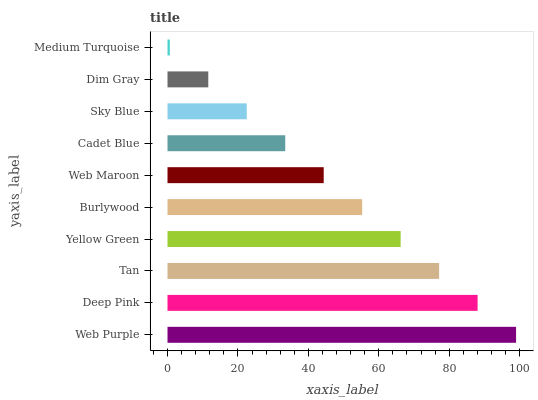Is Medium Turquoise the minimum?
Answer yes or no. Yes. Is Web Purple the maximum?
Answer yes or no. Yes. Is Deep Pink the minimum?
Answer yes or no. No. Is Deep Pink the maximum?
Answer yes or no. No. Is Web Purple greater than Deep Pink?
Answer yes or no. Yes. Is Deep Pink less than Web Purple?
Answer yes or no. Yes. Is Deep Pink greater than Web Purple?
Answer yes or no. No. Is Web Purple less than Deep Pink?
Answer yes or no. No. Is Burlywood the high median?
Answer yes or no. Yes. Is Web Maroon the low median?
Answer yes or no. Yes. Is Web Purple the high median?
Answer yes or no. No. Is Yellow Green the low median?
Answer yes or no. No. 